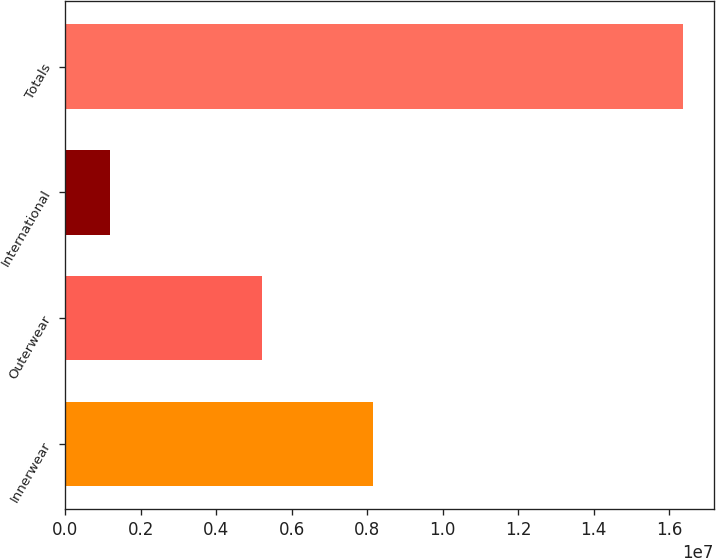Convert chart to OTSL. <chart><loc_0><loc_0><loc_500><loc_500><bar_chart><fcel>Innerwear<fcel>Outerwear<fcel>International<fcel>Totals<nl><fcel>8.1381e+06<fcel>5.21241e+06<fcel>1.17281e+06<fcel>1.63566e+07<nl></chart> 